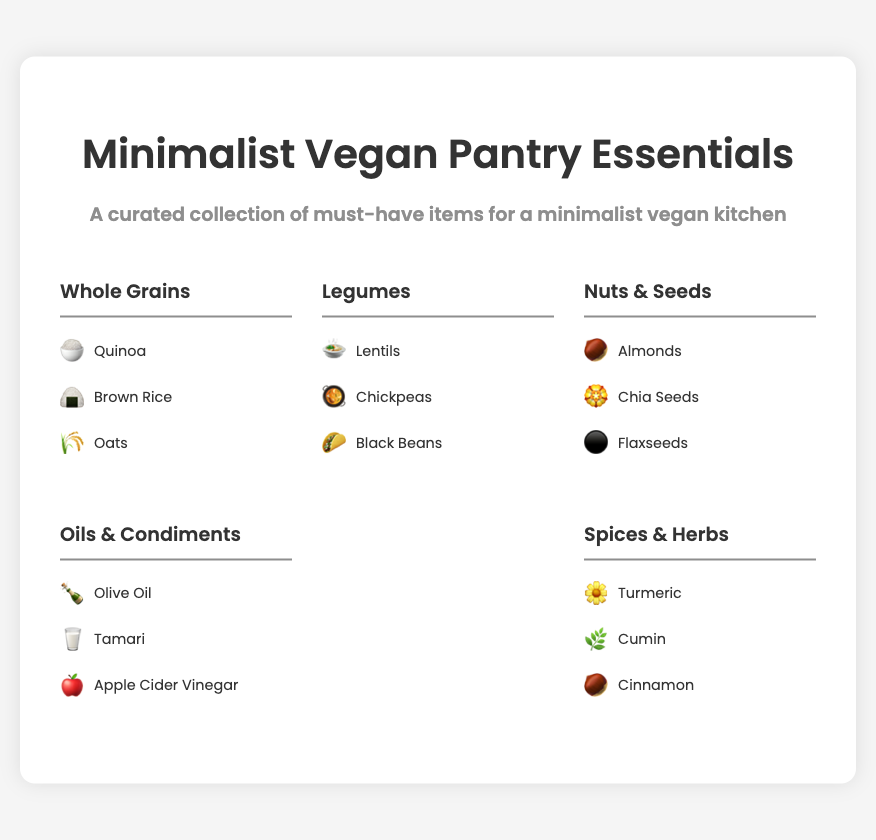What is the title of the poster? The title is prominently displayed at the top of the poster, indicating the main subject.
Answer: Minimalist Vegan Pantry Essentials How many sections are there in the poster? The poster has multiple categories, each representing a different type of pantry essential.
Answer: 5 What is one item listed under Whole Grains? Each section contains examples, and Whole Grains has a few specific items mentioned.
Answer: Quinoa What icon represents Chickpeas? The icon associated with each item helps visualize the content and identify it easily.
Answer: 🥘 Which oil is featured in the Oils & Condiments section? The specific items listed in this section identify necessary pantry items for cooking.
Answer: Olive Oil Name one spice mentioned in the Spices & Herbs section. This section contains essential flavoring agents found in a minimalist vegan kitchen.
Answer: Turmeric What color palette is used in the poster? The design elements contribute to the aesthetic appeal, reflecting a minimalist approach.
Answer: Neutral Which legume is highlighted in the document? Each section focuses on specific categories, with various legumes mentioned.
Answer: Lentils What is the font style used in the poster? The typography adds to the overall visual presentation of the poster's information.
Answer: Poppins 